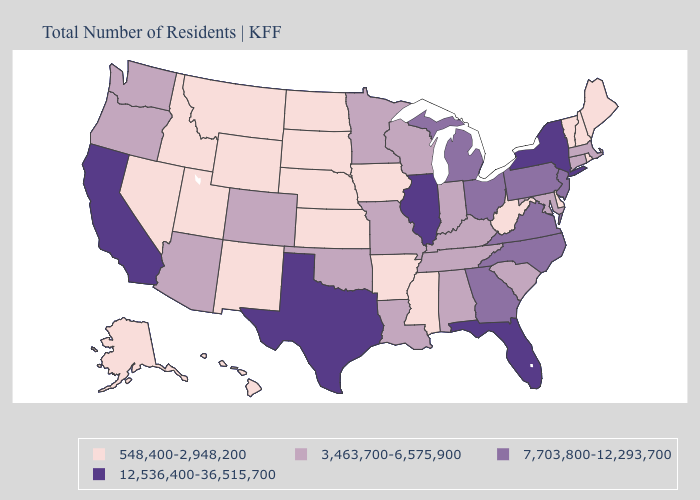Does Tennessee have the same value as Minnesota?
Short answer required. Yes. Does Minnesota have a higher value than Rhode Island?
Write a very short answer. Yes. Which states have the lowest value in the Northeast?
Concise answer only. Maine, New Hampshire, Rhode Island, Vermont. Name the states that have a value in the range 7,703,800-12,293,700?
Answer briefly. Georgia, Michigan, New Jersey, North Carolina, Ohio, Pennsylvania, Virginia. Name the states that have a value in the range 548,400-2,948,200?
Give a very brief answer. Alaska, Arkansas, Delaware, Hawaii, Idaho, Iowa, Kansas, Maine, Mississippi, Montana, Nebraska, Nevada, New Hampshire, New Mexico, North Dakota, Rhode Island, South Dakota, Utah, Vermont, West Virginia, Wyoming. What is the value of Kentucky?
Be succinct. 3,463,700-6,575,900. What is the value of Virginia?
Keep it brief. 7,703,800-12,293,700. Does Illinois have the highest value in the USA?
Be succinct. Yes. Does Colorado have the lowest value in the West?
Give a very brief answer. No. Name the states that have a value in the range 3,463,700-6,575,900?
Give a very brief answer. Alabama, Arizona, Colorado, Connecticut, Indiana, Kentucky, Louisiana, Maryland, Massachusetts, Minnesota, Missouri, Oklahoma, Oregon, South Carolina, Tennessee, Washington, Wisconsin. What is the value of Alabama?
Write a very short answer. 3,463,700-6,575,900. Does Arizona have a higher value than Connecticut?
Quick response, please. No. Does New York have the highest value in the USA?
Be succinct. Yes. What is the highest value in the USA?
Short answer required. 12,536,400-36,515,700. Name the states that have a value in the range 548,400-2,948,200?
Quick response, please. Alaska, Arkansas, Delaware, Hawaii, Idaho, Iowa, Kansas, Maine, Mississippi, Montana, Nebraska, Nevada, New Hampshire, New Mexico, North Dakota, Rhode Island, South Dakota, Utah, Vermont, West Virginia, Wyoming. 